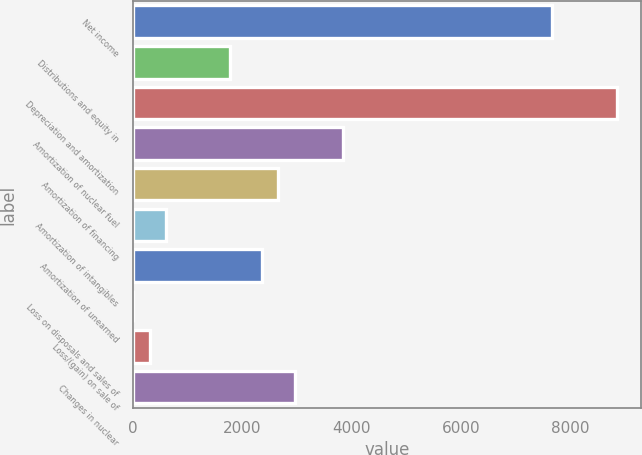Convert chart to OTSL. <chart><loc_0><loc_0><loc_500><loc_500><bar_chart><fcel>Net income<fcel>Distributions and equity in<fcel>Depreciation and amortization<fcel>Amortization of nuclear fuel<fcel>Amortization of financing<fcel>Amortization of intangibles<fcel>Amortization of unearned<fcel>Loss on disposals and sales of<fcel>Loss/(gain) on sale of<fcel>Changes in nuclear<nl><fcel>7669.4<fcel>1771.4<fcel>8849<fcel>3835.7<fcel>2656.1<fcel>591.8<fcel>2361.2<fcel>2<fcel>296.9<fcel>2951<nl></chart> 